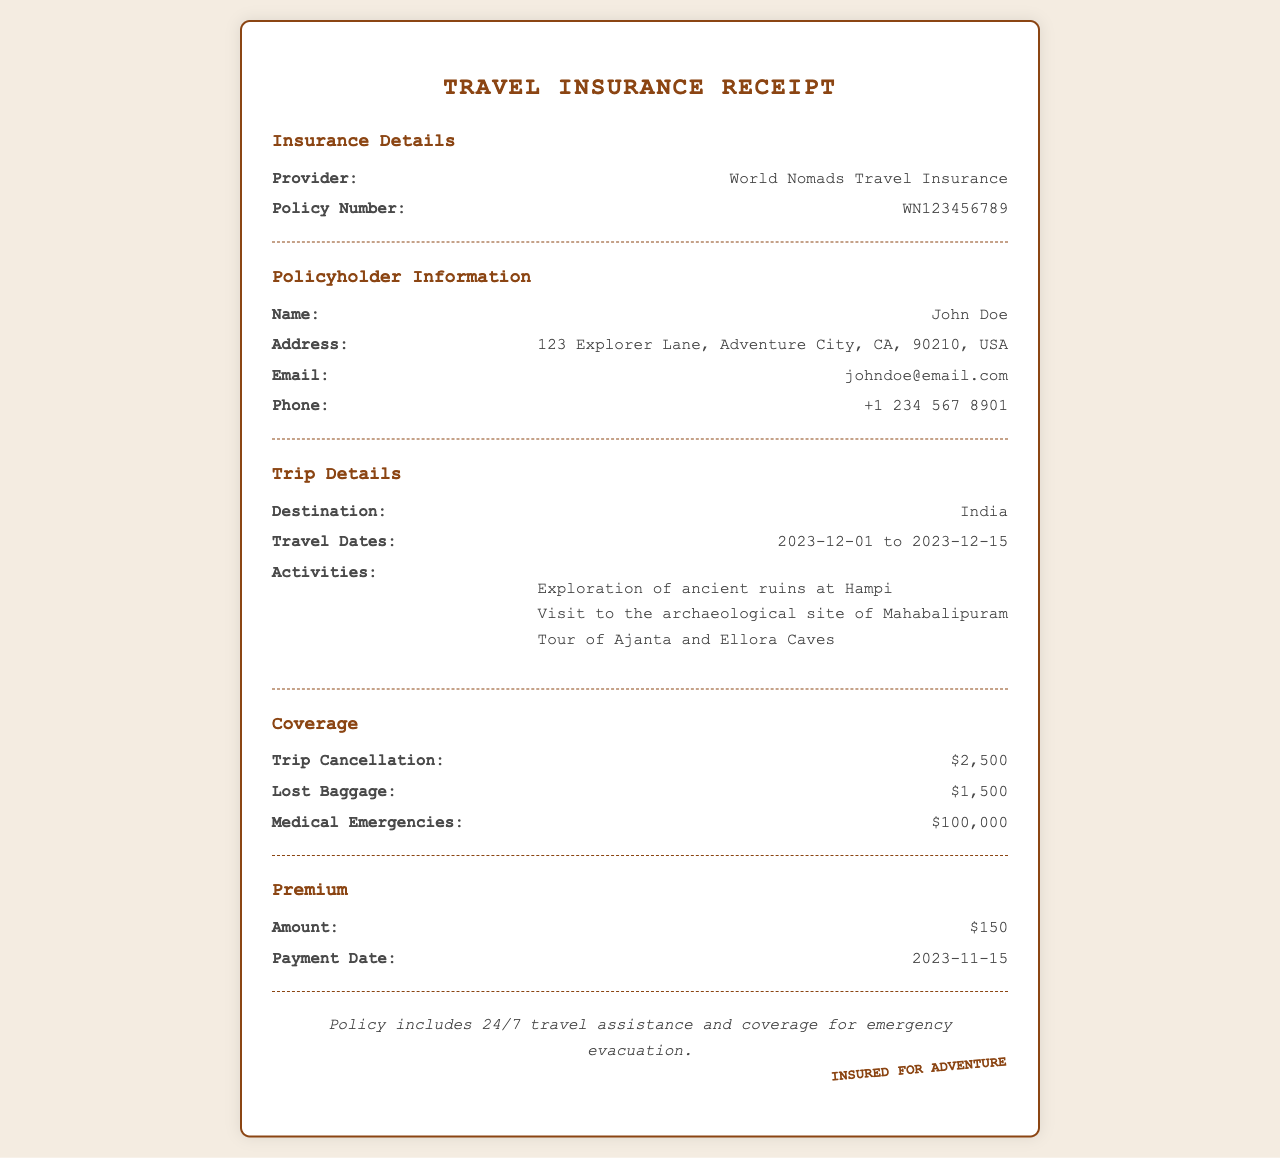What is the insurance provider? The document states the insurance provider as World Nomads Travel Insurance.
Answer: World Nomads Travel Insurance What is the policy number? The policy number can be found in the insurance details section, listed as WN123456789.
Answer: WN123456789 What is the coverage amount for medical emergencies? The document specifies the coverage amount for medical emergencies as $100,000.
Answer: $100,000 What are the travel dates? The travel dates are indicated in the trip details section as from 2023-12-01 to 2023-12-15.
Answer: 2023-12-01 to 2023-12-15 What is the amount of the premium? The amount of the premium is given in the premium section as $150.
Answer: $150 Which activity involves visiting ancient ruins? The activity involving visiting ancient ruins is specifically the exploration of ancient ruins at Hampi.
Answer: Exploration of ancient ruins at Hampi What is the total coverage for trip cancellation and lost baggage? The total coverage can be calculated by adding the coverage amounts for trip cancellation ($2,500) and lost baggage ($1,500), which totals $4,000.
Answer: $4,000 On what date was the premium payment made? The payment date for the premium is stated as 2023-11-15 in the premium section.
Answer: 2023-11-15 What kind of assistance is included with the policy? The document notes that the policy includes 24/7 travel assistance.
Answer: 24/7 travel assistance 